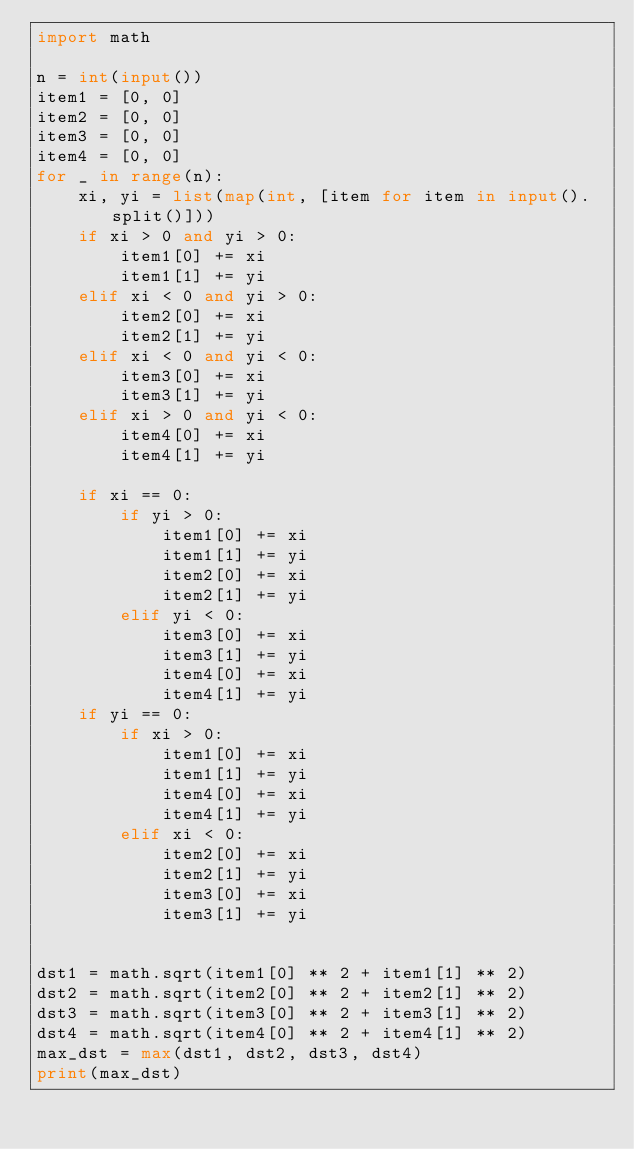<code> <loc_0><loc_0><loc_500><loc_500><_Python_>import math

n = int(input())
item1 = [0, 0]
item2 = [0, 0]
item3 = [0, 0]
item4 = [0, 0]
for _ in range(n):
    xi, yi = list(map(int, [item for item in input().split()]))
    if xi > 0 and yi > 0:
        item1[0] += xi
        item1[1] += yi
    elif xi < 0 and yi > 0:
        item2[0] += xi
        item2[1] += yi
    elif xi < 0 and yi < 0:
        item3[0] += xi
        item3[1] += yi
    elif xi > 0 and yi < 0:
        item4[0] += xi
        item4[1] += yi

    if xi == 0:
        if yi > 0:
            item1[0] += xi
            item1[1] += yi
            item2[0] += xi
            item2[1] += yi
        elif yi < 0:
            item3[0] += xi
            item3[1] += yi
            item4[0] += xi
            item4[1] += yi
    if yi == 0:
        if xi > 0:
            item1[0] += xi
            item1[1] += yi
            item4[0] += xi
            item4[1] += yi
        elif xi < 0:
            item2[0] += xi
            item2[1] += yi
            item3[0] += xi
            item3[1] += yi


dst1 = math.sqrt(item1[0] ** 2 + item1[1] ** 2)
dst2 = math.sqrt(item2[0] ** 2 + item2[1] ** 2)
dst3 = math.sqrt(item3[0] ** 2 + item3[1] ** 2)
dst4 = math.sqrt(item4[0] ** 2 + item4[1] ** 2)
max_dst = max(dst1, dst2, dst3, dst4)
print(max_dst)

</code> 